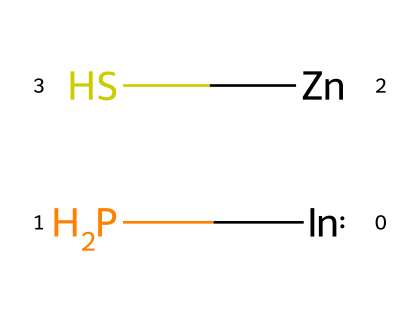What is the main element in this quantum dot structure? The main element in the InP/ZnS quantum dot structure is Indium (In), as represented by the first part of the SMILES notation.
Answer: Indium How many different elements are present in this quantum dot? The SMILES notation shows three elements: Indium (In), Phosphorus (P), Zinc (Zn), and Sulfur (S). Thus, there are four distinct elements in total.
Answer: four What type of bonding is likely present between the elements in this quantum dot? The presence of metal and non-metal elements suggests ionic and covalent bonding; specifically, InP likely has covalent bonds, while ZnS may exhibit ionic characteristics due to the difference in electronegativity.
Answer: ionic and covalent What are the core and shell materials in this quantum dot? InP serves as the core material due to Indium Phosphide composition, while ZnS acts as the shell material that provides passivation and stability to the quantum dot.
Answer: InP core, ZnS shell What is the potential application of InP/ZnS quantum dots in biotechnology? InP/ZnS quantum dots are known for their use as biocompatible imaging probes due to their fluorescence properties in biological systems.
Answer: biocompatible imaging probes Why is biocompatibility important for quantum dots used in biological systems? Biocompatibility ensures that quantum dots do not elicit immune responses or toxicity in living organisms, making them safer for use in medical imaging and therapies.
Answer: safety 